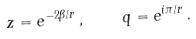<formula> <loc_0><loc_0><loc_500><loc_500>z = e ^ { - 2 \beta / r } \, , \quad q = e ^ { i \pi / r } \, .</formula> 